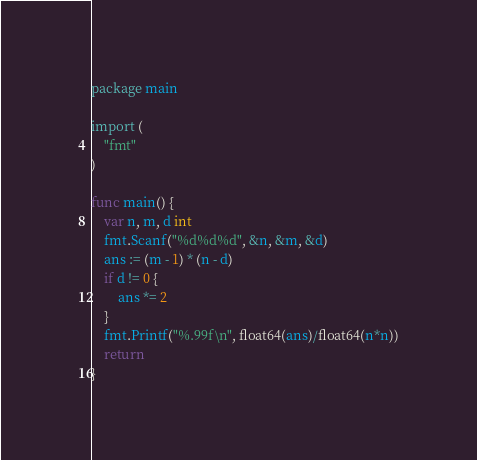<code> <loc_0><loc_0><loc_500><loc_500><_Go_>package main

import (
	"fmt"
)

func main() {
	var n, m, d int
	fmt.Scanf("%d%d%d", &n, &m, &d)
	ans := (m - 1) * (n - d)
	if d != 0 {
		ans *= 2
	}
	fmt.Printf("%.99f\n", float64(ans)/float64(n*n))
	return
}
</code> 